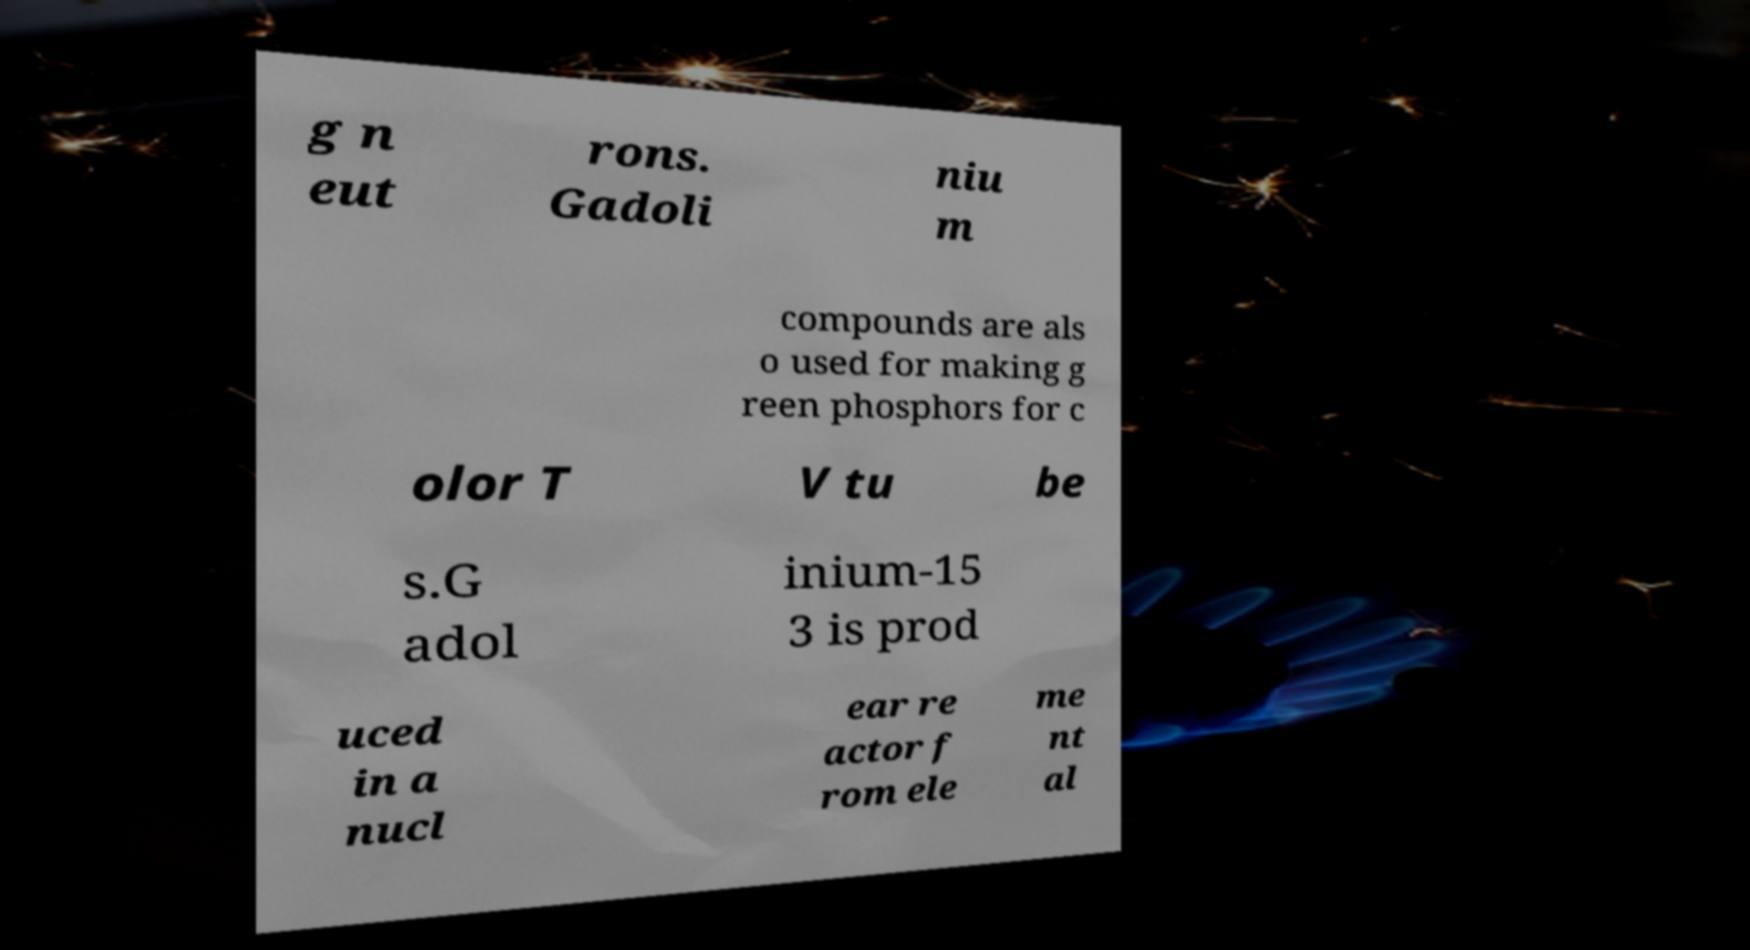There's text embedded in this image that I need extracted. Can you transcribe it verbatim? g n eut rons. Gadoli niu m compounds are als o used for making g reen phosphors for c olor T V tu be s.G adol inium-15 3 is prod uced in a nucl ear re actor f rom ele me nt al 